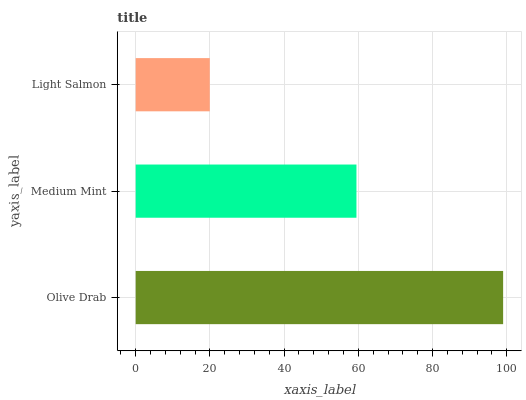Is Light Salmon the minimum?
Answer yes or no. Yes. Is Olive Drab the maximum?
Answer yes or no. Yes. Is Medium Mint the minimum?
Answer yes or no. No. Is Medium Mint the maximum?
Answer yes or no. No. Is Olive Drab greater than Medium Mint?
Answer yes or no. Yes. Is Medium Mint less than Olive Drab?
Answer yes or no. Yes. Is Medium Mint greater than Olive Drab?
Answer yes or no. No. Is Olive Drab less than Medium Mint?
Answer yes or no. No. Is Medium Mint the high median?
Answer yes or no. Yes. Is Medium Mint the low median?
Answer yes or no. Yes. Is Light Salmon the high median?
Answer yes or no. No. Is Light Salmon the low median?
Answer yes or no. No. 